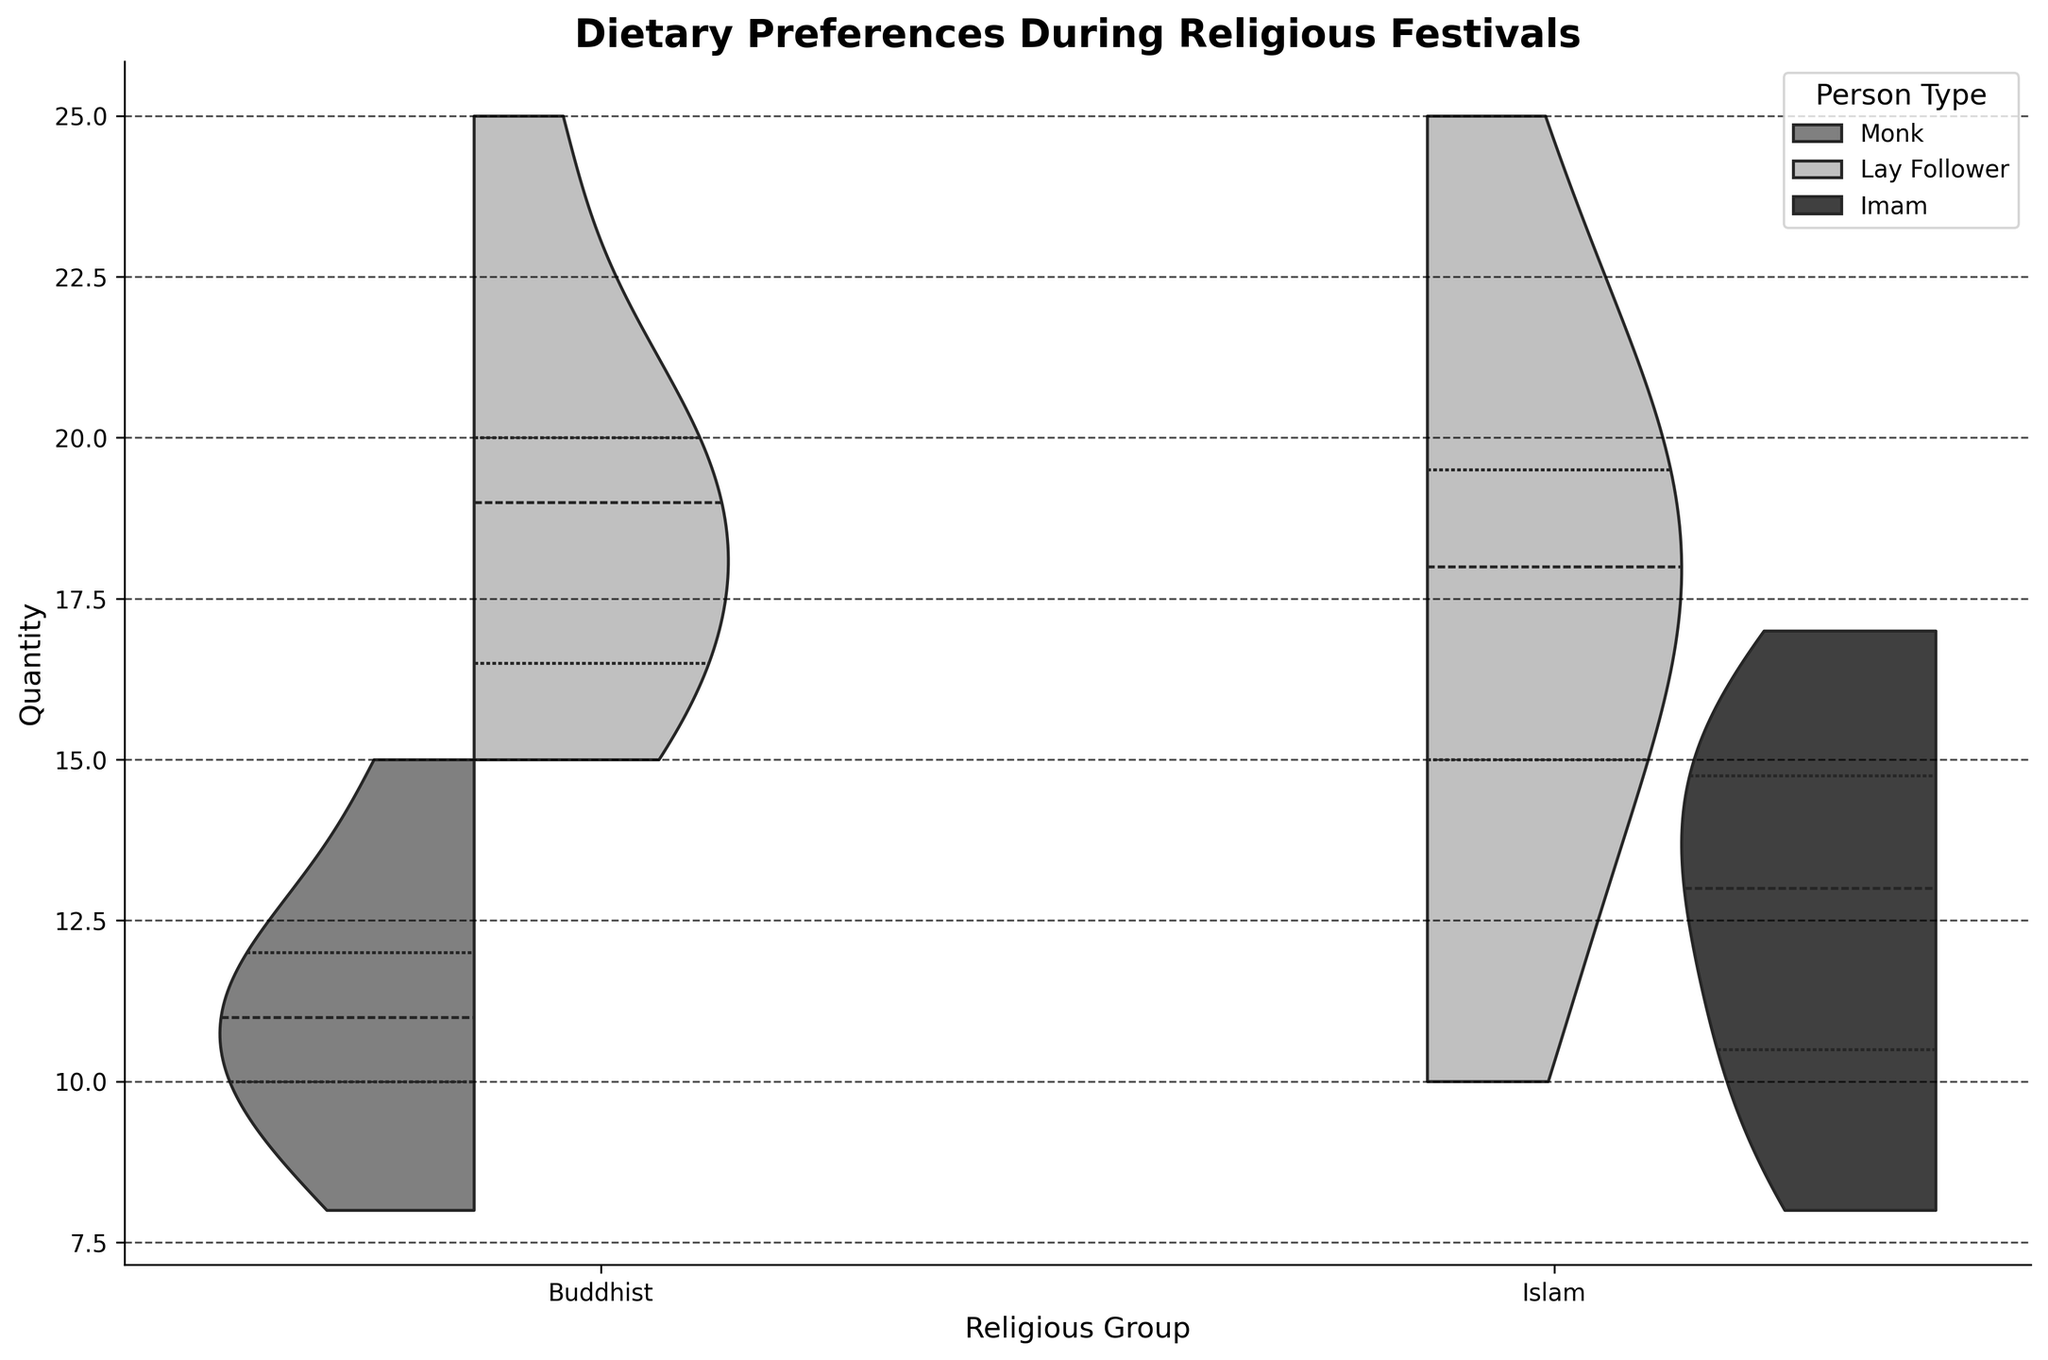What is the title of the figure? The title is displayed at the top of the figure.
Answer: Dietary Preferences During Religious Festivals What are the two types of people within the Buddhist group? The person types are labeled in the plot legend.
Answer: Monk and Lay Follower What does a "split" violin plot mean in this figure? A split violin plot shows two distributions side by side within the same category, helping to compare them directly.
Answer: It splits the distributions for comparing Monk and Lay Follower Which person type in the Buddhist group appears to consume more food? The distribution for Lay Follower is centered at higher quantities compared to Monk.
Answer: Lay Follower What can you infer about the quantity distribution among Imams during Milad an-Nabi compared to Lay Followers? The Lay Follower distribution seems to be centered around higher values than the Imam distribution for Milad an-Nabi, indicating they consume more.
Answer: Lay Follower generally consumes more What is the range of food quantities consumed by Monks during Songkran? The range is determined by the spread of the Monks' distribution in the Songkran part of the plot.
Answer: 10 to 15 How do Lay Followers' quantity distributions compare between Loy Krathong and Songkran within the Buddhist group? The distributions for Songkran appear to have a wider range and higher median than for Loy Krathong.
Answer: Higher and broader in Songkran Which group has a more varied diet during festivals: Monks, Lay Followers (Buddhist), or Imams? The width of the violin plots represents variation; comparing them indicates Lay Followers (Buddhist) have a broader diet.
Answer: Lay Followers (Buddhist) During Eid al-Fitr, which food item is consumed more by Lay Followers on average, Samosa or Biryani? The violin plot for Lay Followers during Eid al-Fitr shows a higher center for Biryani compared to Samosa.
Answer: Biryani For which festival do the Imams show the smallest range of dietary preferences? The narrowest distribution range for Imams indicates the smallest variety, observed in Eid al-Fitr.
Answer: Eid al-Fitr 